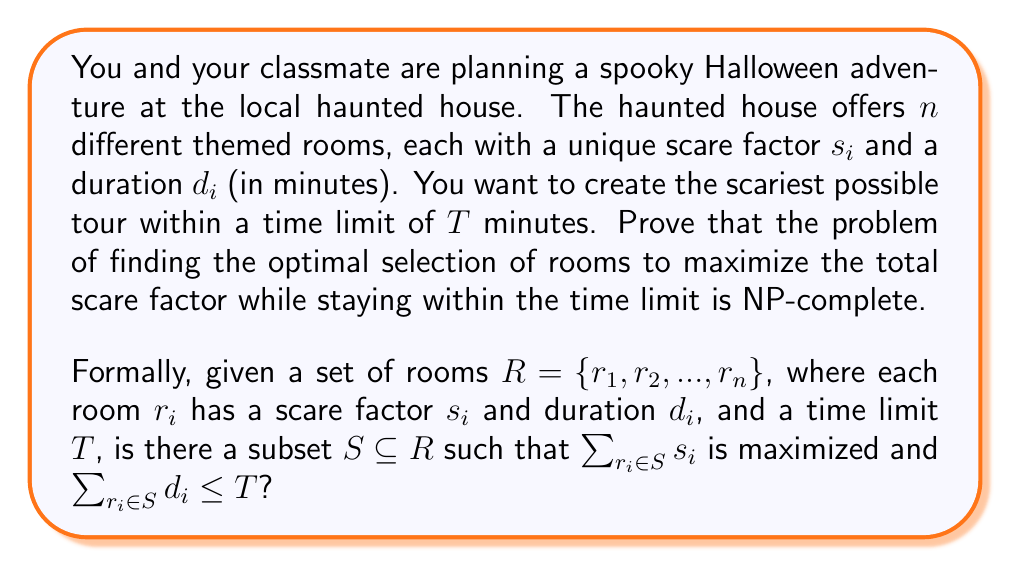Can you answer this question? To prove that this problem is NP-complete, we need to show that it is both in NP and NP-hard.

1. Prove the problem is in NP:
   A problem is in NP if we can verify a solution in polynomial time. In this case, given a subset of rooms, we can easily check if the total duration is within the time limit and calculate the total scare factor in linear time. Therefore, the problem is in NP.

2. Prove the problem is NP-hard:
   We can prove NP-hardness by reducing a known NP-complete problem to our problem. In this case, we'll use the 0-1 Knapsack problem, which is known to be NP-complete.

   The 0-1 Knapsack problem is defined as follows:
   Given a set of items, each with a weight $w_i$ and a value $v_i$, and a knapsack capacity $W$, find a subset of items to maximize the total value while keeping the total weight less than or equal to $W$.

   Reduction:
   - Map each item in the Knapsack problem to a room in our problem.
   - Set the scare factor $s_i$ of each room to the value $v_i$ of the corresponding item.
   - Set the duration $d_i$ of each room to the weight $w_i$ of the corresponding item.
   - Set the time limit $T$ to the knapsack capacity $W$.

   This reduction can be done in polynomial time, and it's easy to see that a solution to the Knapsack problem directly corresponds to a solution to our Haunted House Tour problem.

   If we could solve the Haunted House Tour problem in polynomial time, we could also solve the 0-1 Knapsack problem in polynomial time. Since the 0-1 Knapsack problem is NP-complete, our problem must be at least as hard, and therefore NP-hard.

3. Conclusion:
   Since the Haunted House Tour problem is both in NP and NP-hard, it is NP-complete.
Answer: The Haunted House Tour problem is NP-complete. 